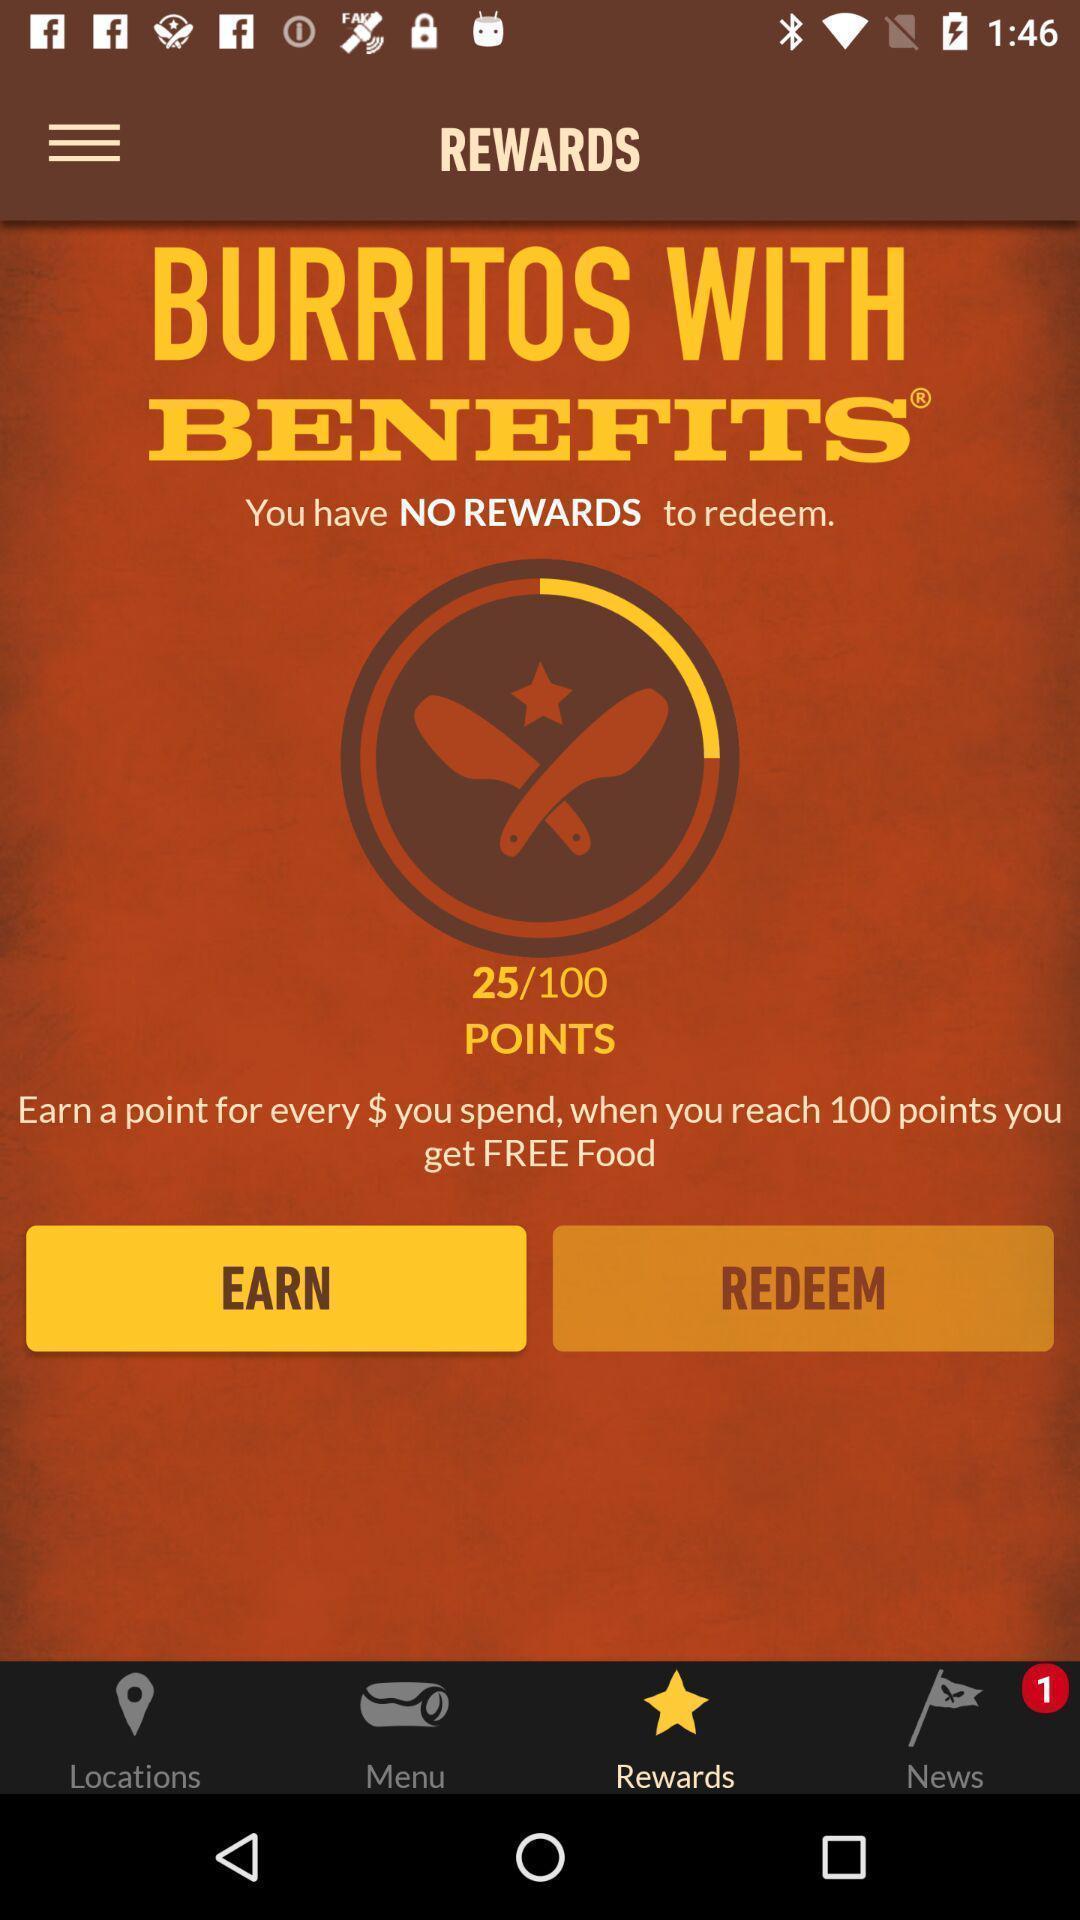Give me a summary of this screen capture. Screen shows about rewards program. 